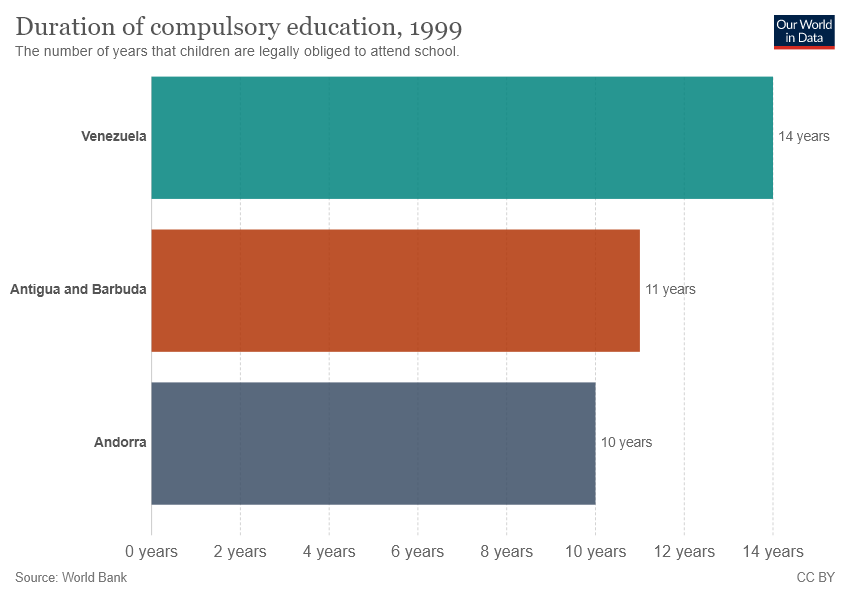Mention a couple of crucial points in this snapshot. The color green represents the age group of 14 to 18 years old in the bar graph. The orange bar is one year difference from the gray bar. Yes. 